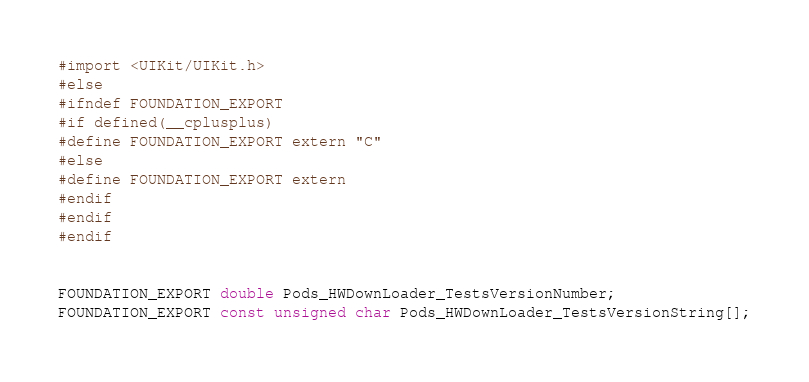<code> <loc_0><loc_0><loc_500><loc_500><_C_>#import <UIKit/UIKit.h>
#else
#ifndef FOUNDATION_EXPORT
#if defined(__cplusplus)
#define FOUNDATION_EXPORT extern "C"
#else
#define FOUNDATION_EXPORT extern
#endif
#endif
#endif


FOUNDATION_EXPORT double Pods_HWDownLoader_TestsVersionNumber;
FOUNDATION_EXPORT const unsigned char Pods_HWDownLoader_TestsVersionString[];

</code> 